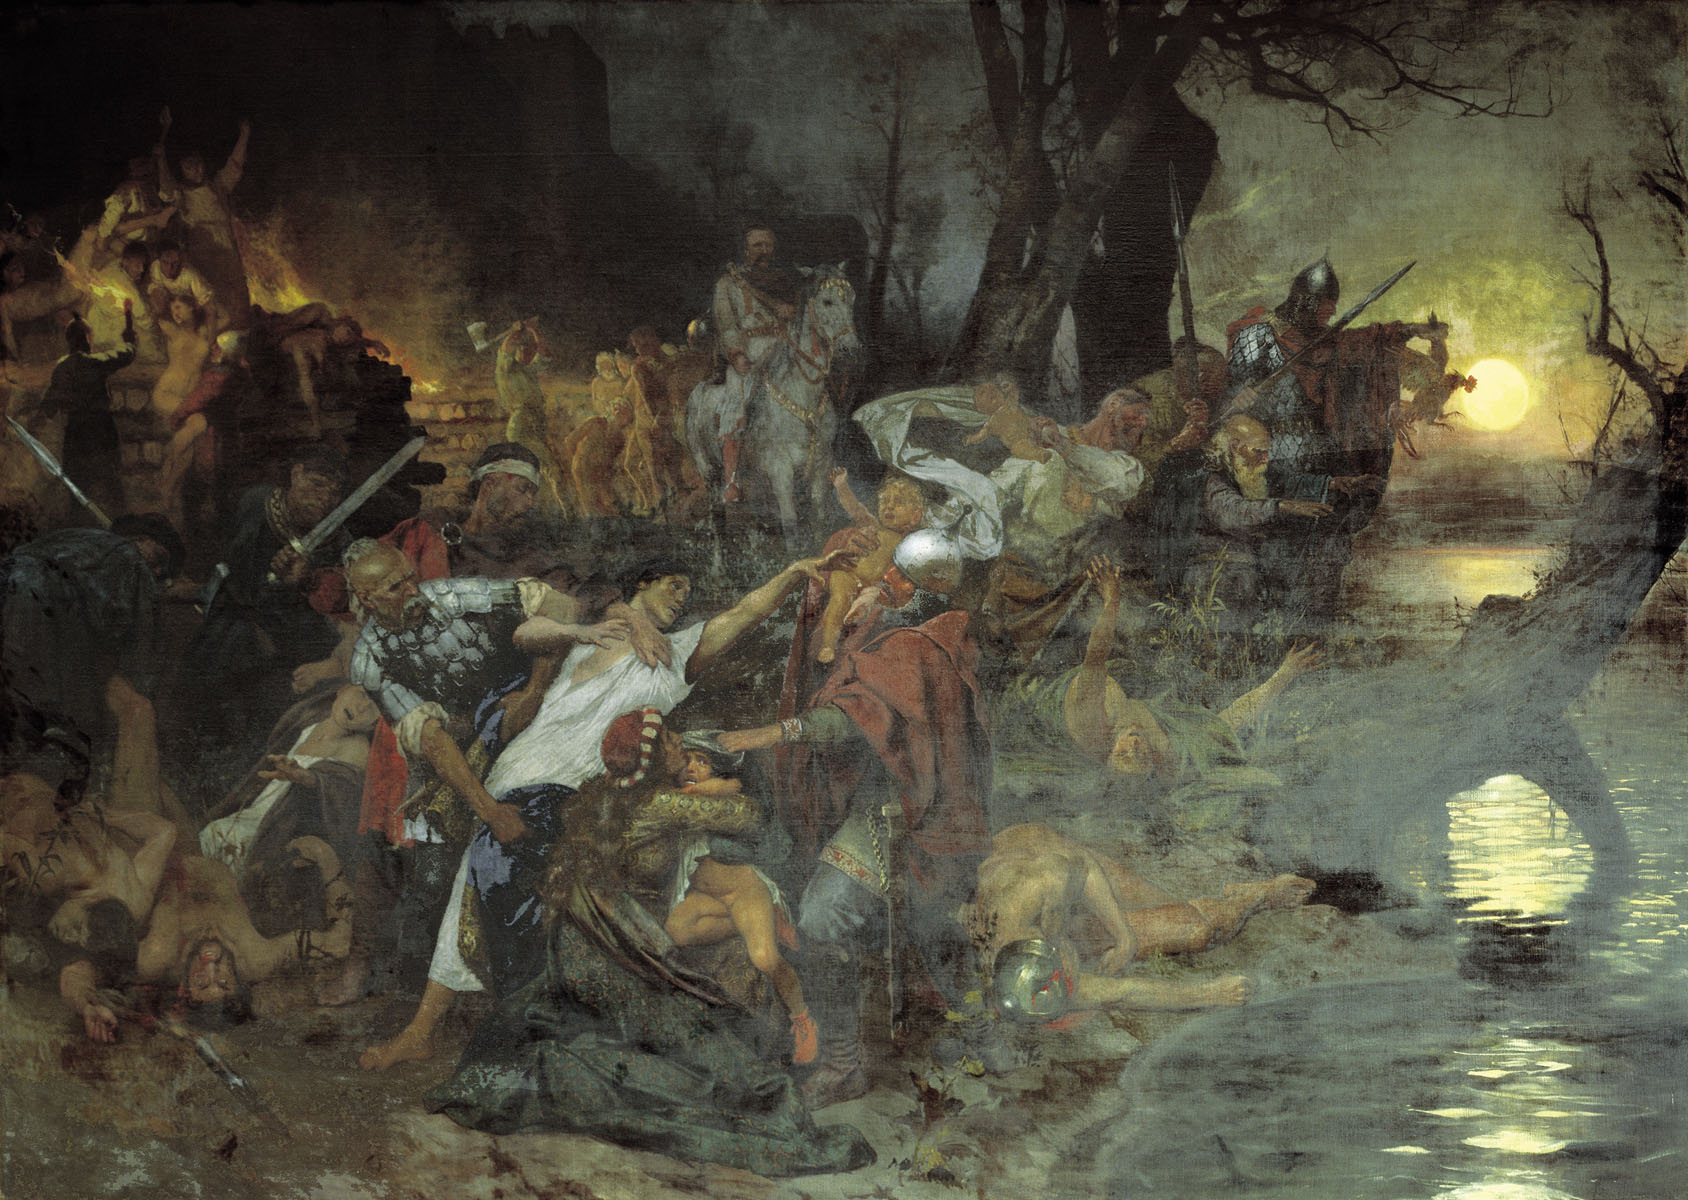What does the moon symbolize in this painting? The moon in this painting likely symbolizes the dual nature of enlightenment and lunacy. Its eerie illumination amidst the dark scene enhances the overall sense of eeriness and may represent the thin line between sanity and madness that battle often engenders. The moon also casts light on the grim realities of conflict, making it impossible for the horrors to hide in darkness. 